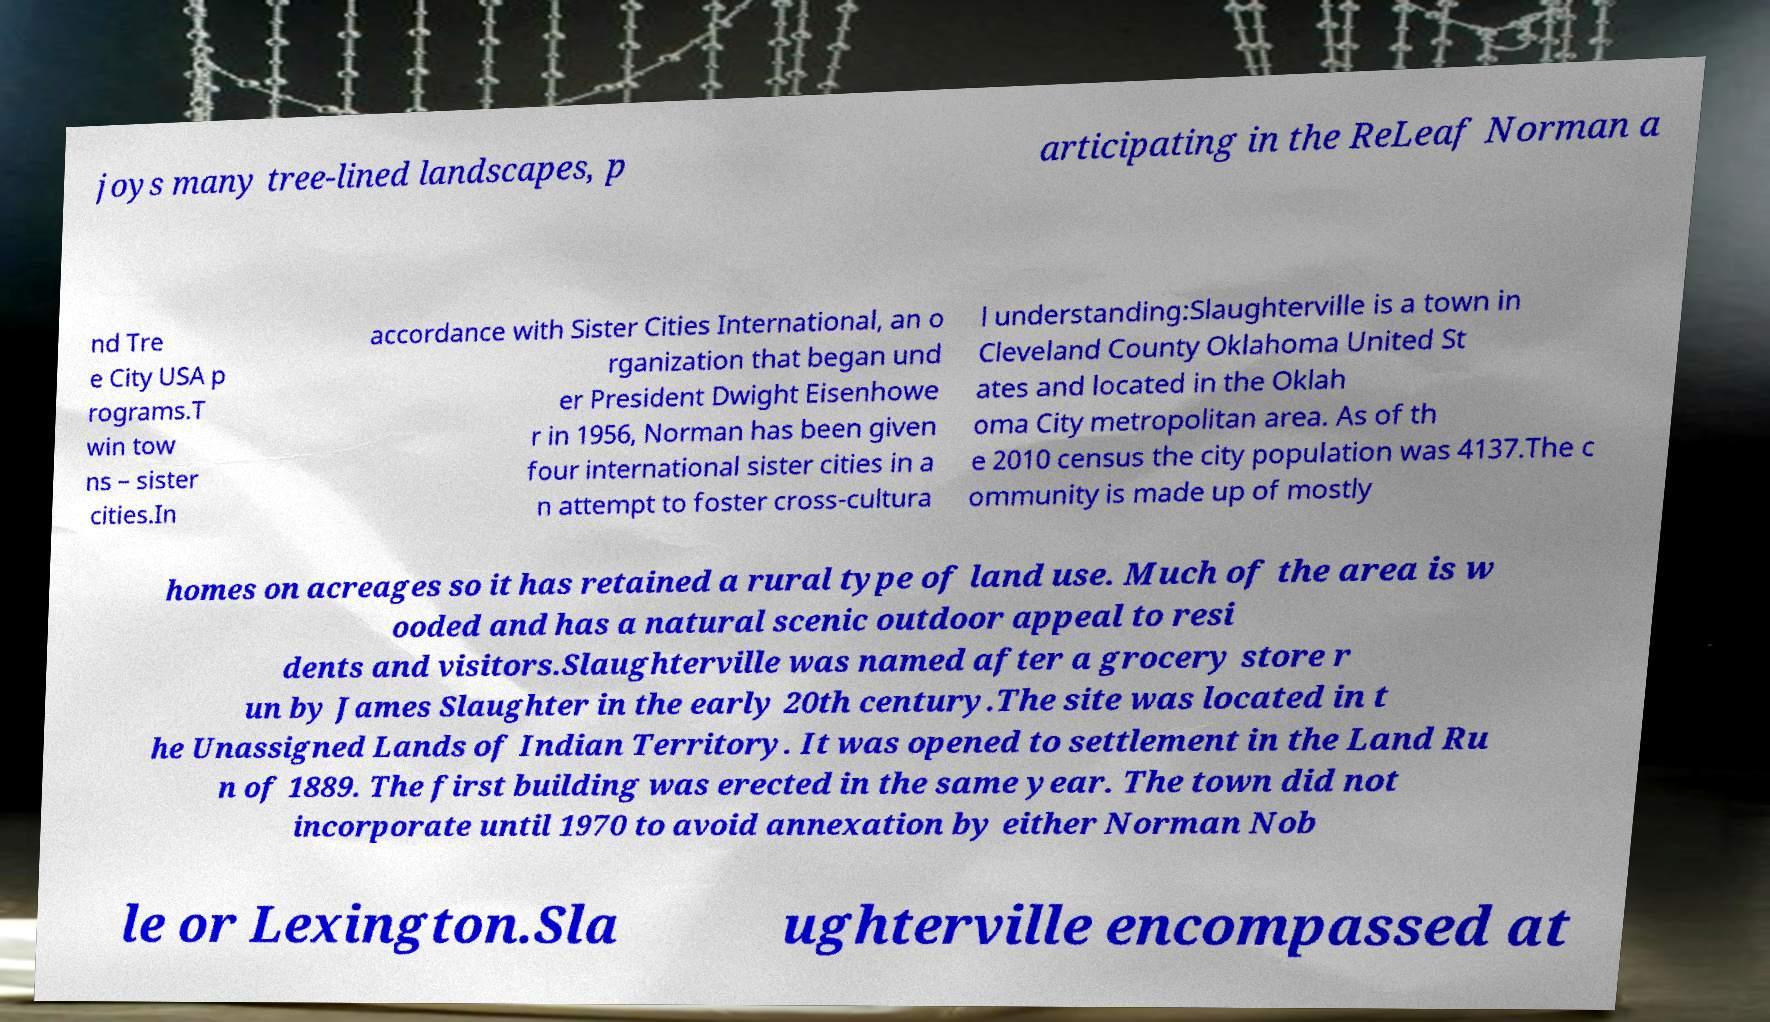What messages or text are displayed in this image? I need them in a readable, typed format. joys many tree-lined landscapes, p articipating in the ReLeaf Norman a nd Tre e City USA p rograms.T win tow ns – sister cities.In accordance with Sister Cities International, an o rganization that began und er President Dwight Eisenhowe r in 1956, Norman has been given four international sister cities in a n attempt to foster cross-cultura l understanding:Slaughterville is a town in Cleveland County Oklahoma United St ates and located in the Oklah oma City metropolitan area. As of th e 2010 census the city population was 4137.The c ommunity is made up of mostly homes on acreages so it has retained a rural type of land use. Much of the area is w ooded and has a natural scenic outdoor appeal to resi dents and visitors.Slaughterville was named after a grocery store r un by James Slaughter in the early 20th century.The site was located in t he Unassigned Lands of Indian Territory. It was opened to settlement in the Land Ru n of 1889. The first building was erected in the same year. The town did not incorporate until 1970 to avoid annexation by either Norman Nob le or Lexington.Sla ughterville encompassed at 